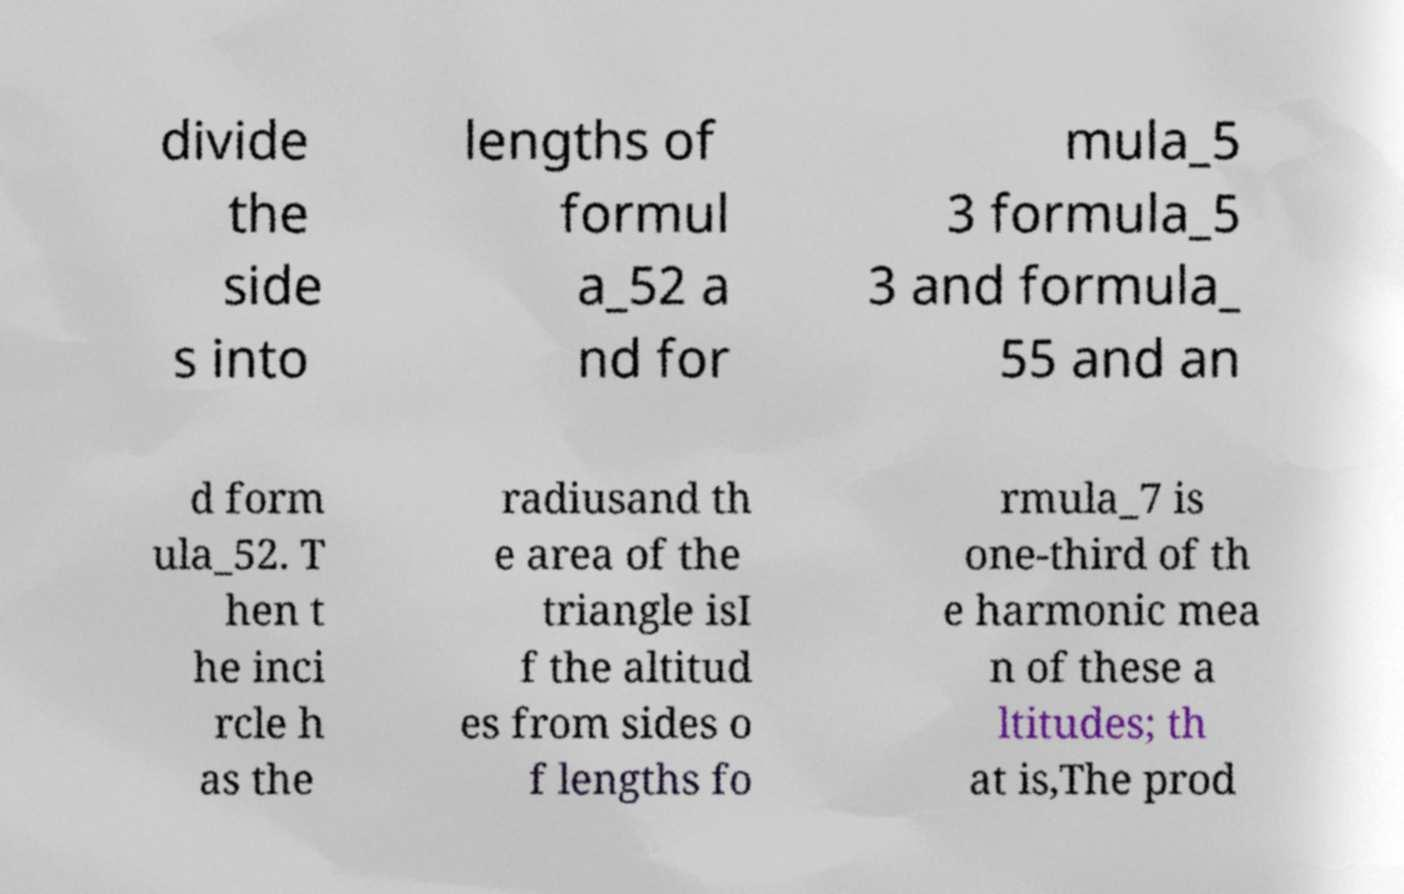There's text embedded in this image that I need extracted. Can you transcribe it verbatim? divide the side s into lengths of formul a_52 a nd for mula_5 3 formula_5 3 and formula_ 55 and an d form ula_52. T hen t he inci rcle h as the radiusand th e area of the triangle isI f the altitud es from sides o f lengths fo rmula_7 is one-third of th e harmonic mea n of these a ltitudes; th at is,The prod 